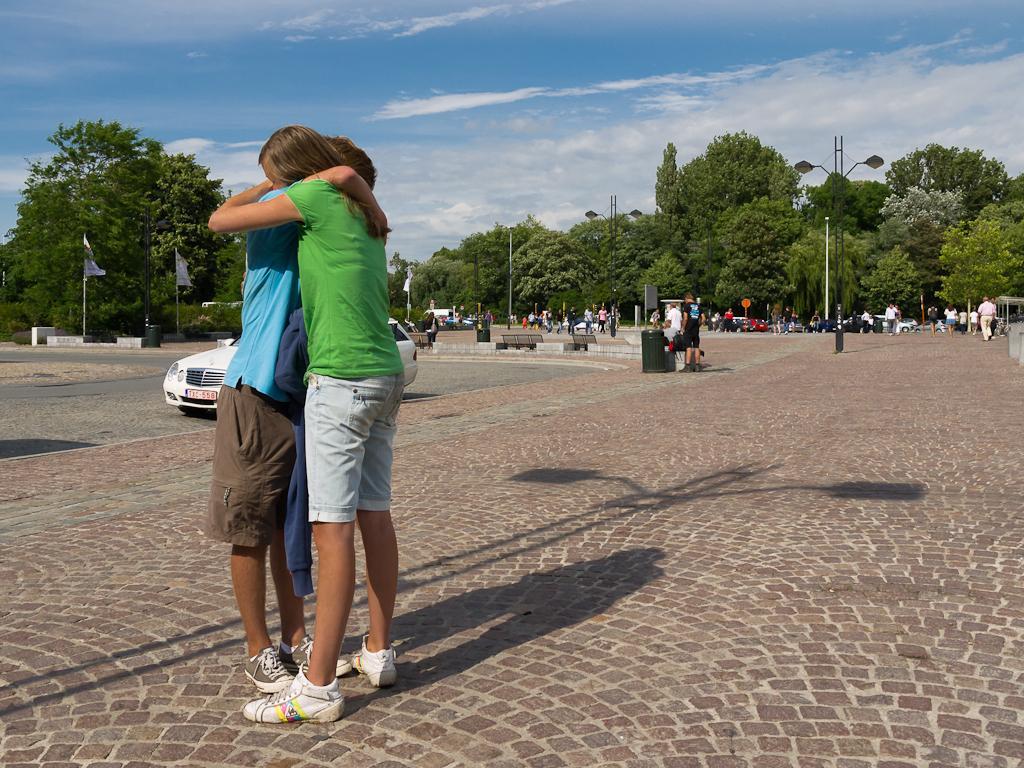Please provide a concise description of this image. In front of the picture, we see a man in blue T-shirt and the woman in green T-shirt are standing. They are hugging each other. Behind them, we see a white car is moving on the road. In the background, we see people are walking on the pavement. We even see the benches and garbage bins. There are trees, street lights and poles in the background. On the left side, we see the flagpoles and flags in white color. At the top, we see the sky. It is a sunny day. 